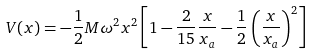Convert formula to latex. <formula><loc_0><loc_0><loc_500><loc_500>V ( x ) = - \frac { 1 } { 2 } M \omega ^ { 2 } x ^ { 2 } \left [ 1 - \frac { 2 } { 1 5 } \frac { x } { x _ { a } } - \frac { 1 } { 2 } \left ( \frac { x } { x _ { a } } \right ) ^ { 2 } \right ]</formula> 